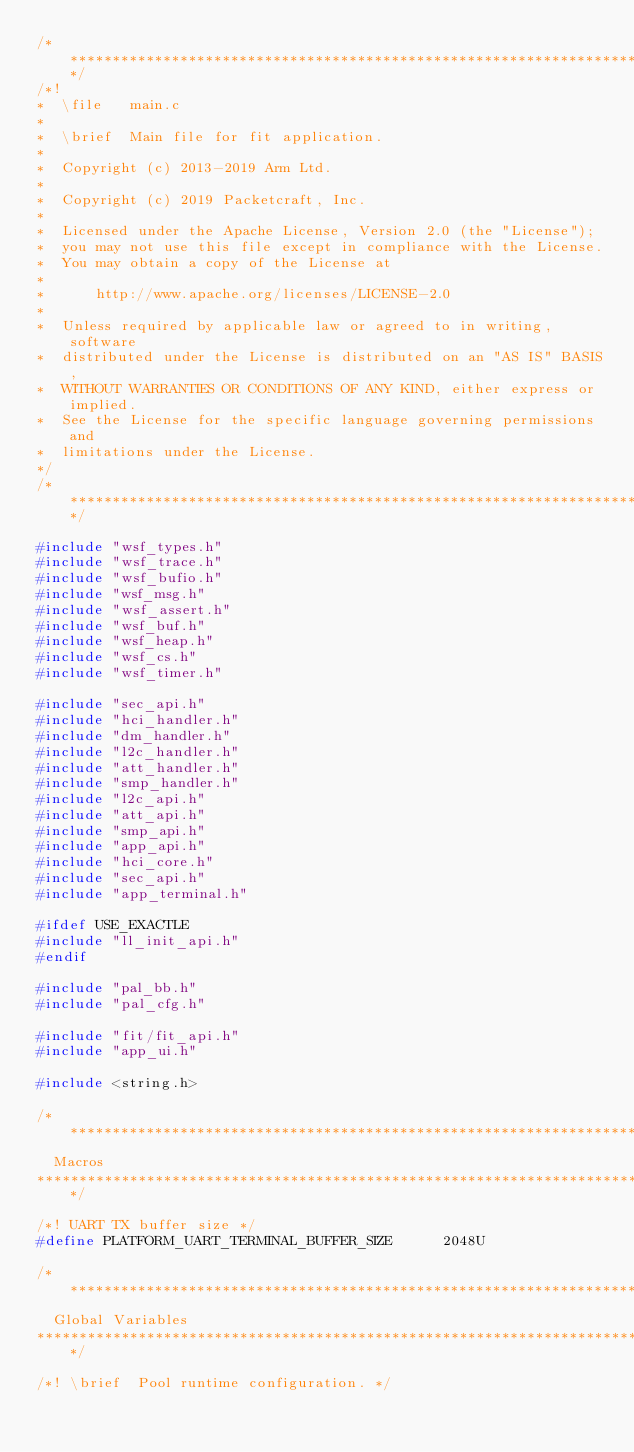Convert code to text. <code><loc_0><loc_0><loc_500><loc_500><_C_>/*************************************************************************************************/
/*!
*  \file   main.c
*
*  \brief  Main file for fit application.
*
*  Copyright (c) 2013-2019 Arm Ltd.
*
*  Copyright (c) 2019 Packetcraft, Inc.
*
*  Licensed under the Apache License, Version 2.0 (the "License");
*  you may not use this file except in compliance with the License.
*  You may obtain a copy of the License at
*
*      http://www.apache.org/licenses/LICENSE-2.0
*
*  Unless required by applicable law or agreed to in writing, software
*  distributed under the License is distributed on an "AS IS" BASIS,
*  WITHOUT WARRANTIES OR CONDITIONS OF ANY KIND, either express or implied.
*  See the License for the specific language governing permissions and
*  limitations under the License.
*/
/*************************************************************************************************/

#include "wsf_types.h"
#include "wsf_trace.h"
#include "wsf_bufio.h"
#include "wsf_msg.h"
#include "wsf_assert.h"
#include "wsf_buf.h"
#include "wsf_heap.h"
#include "wsf_cs.h"
#include "wsf_timer.h"

#include "sec_api.h"
#include "hci_handler.h"
#include "dm_handler.h"
#include "l2c_handler.h"
#include "att_handler.h"
#include "smp_handler.h"
#include "l2c_api.h"
#include "att_api.h"
#include "smp_api.h"
#include "app_api.h"
#include "hci_core.h"
#include "sec_api.h"
#include "app_terminal.h"

#ifdef USE_EXACTLE
#include "ll_init_api.h"
#endif

#include "pal_bb.h"
#include "pal_cfg.h"

#include "fit/fit_api.h"
#include "app_ui.h"

#include <string.h>

/**************************************************************************************************
  Macros
**************************************************************************************************/

/*! UART TX buffer size */
#define PLATFORM_UART_TERMINAL_BUFFER_SIZE      2048U

/**************************************************************************************************
  Global Variables
**************************************************************************************************/

/*! \brief  Pool runtime configuration. */</code> 